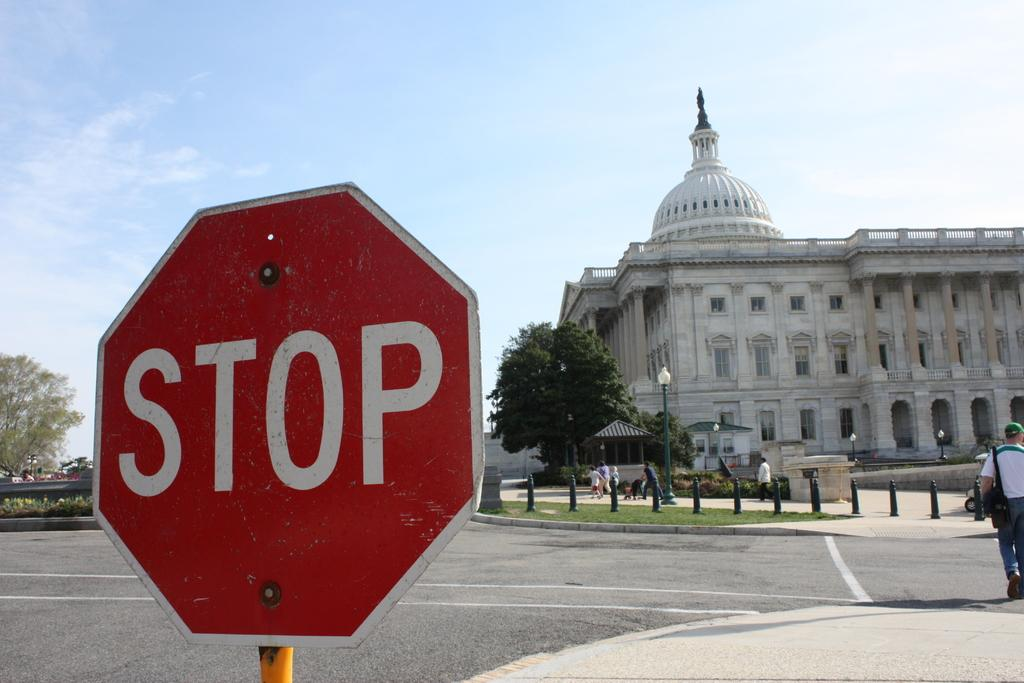<image>
Relay a brief, clear account of the picture shown. a stop sign that is outside in the day 